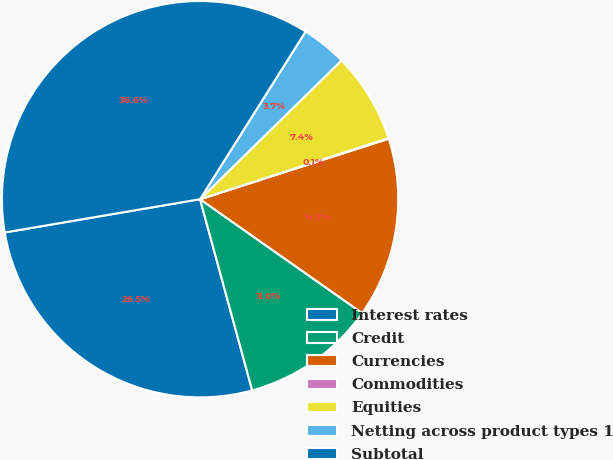Convert chart. <chart><loc_0><loc_0><loc_500><loc_500><pie_chart><fcel>Interest rates<fcel>Credit<fcel>Currencies<fcel>Commodities<fcel>Equities<fcel>Netting across product types 1<fcel>Subtotal<nl><fcel>26.55%<fcel>11.02%<fcel>14.68%<fcel>0.05%<fcel>7.36%<fcel>3.71%<fcel>36.63%<nl></chart> 